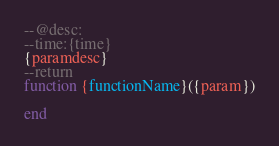<code> <loc_0><loc_0><loc_500><loc_500><_Lua_>--@desc: 
--time:{time}
{paramdesc}
--return 
function {functionName}({param})
	
end</code> 